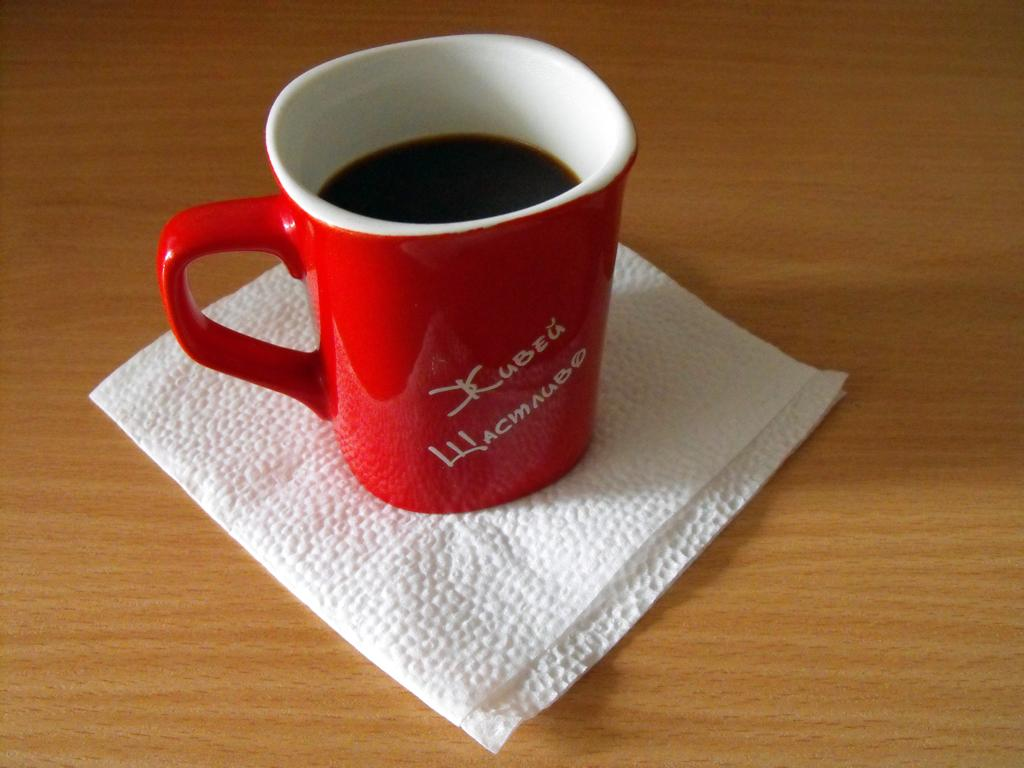What piece of furniture is present in the image? There is a table in the image. What item can be seen on the table? There is a tissue on the table. What else is on the table besides the tissue? There is a cup with a drink on the table. What type of record is being played on the table in the image? There is no record or record player present in the image. 